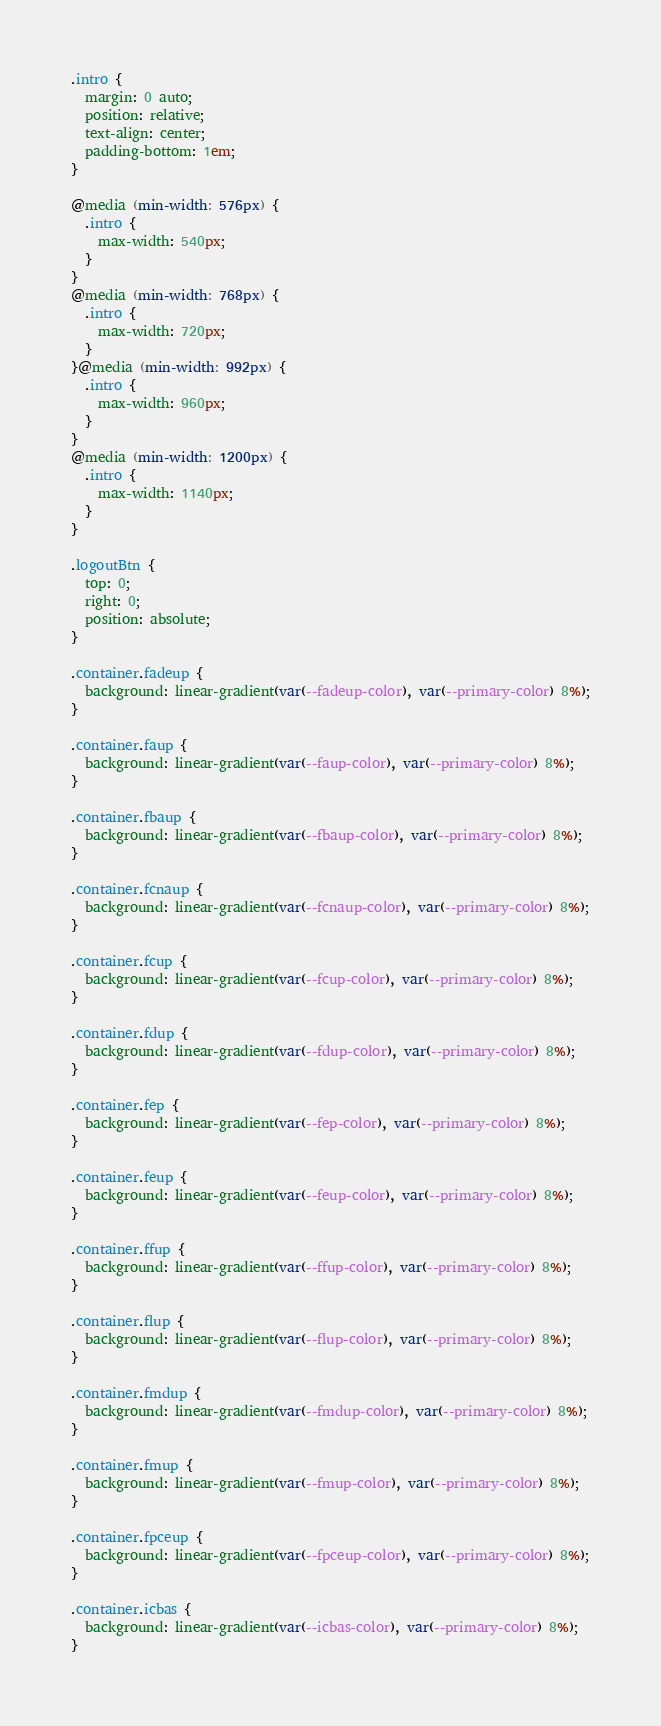<code> <loc_0><loc_0><loc_500><loc_500><_CSS_>.intro {
  margin: 0 auto;
  position: relative;
  text-align: center;
  padding-bottom: 1em;
}

@media (min-width: 576px) {
  .intro {
    max-width: 540px;
  }
}
@media (min-width: 768px) {
  .intro {
    max-width: 720px;
  }
}@media (min-width: 992px) {
  .intro {
    max-width: 960px;
  }
}
@media (min-width: 1200px) {
  .intro {
    max-width: 1140px;
  }
}

.logoutBtn {
  top: 0;
  right: 0;
  position: absolute;
}

.container.fadeup {
  background: linear-gradient(var(--fadeup-color), var(--primary-color) 8%);
}

.container.faup {
  background: linear-gradient(var(--faup-color), var(--primary-color) 8%);
}

.container.fbaup {
  background: linear-gradient(var(--fbaup-color), var(--primary-color) 8%);
}

.container.fcnaup {
  background: linear-gradient(var(--fcnaup-color), var(--primary-color) 8%);
}

.container.fcup {
  background: linear-gradient(var(--fcup-color), var(--primary-color) 8%);
}

.container.fdup {
  background: linear-gradient(var(--fdup-color), var(--primary-color) 8%);
}

.container.fep {
  background: linear-gradient(var(--fep-color), var(--primary-color) 8%);
}

.container.feup {
  background: linear-gradient(var(--feup-color), var(--primary-color) 8%);
}

.container.ffup {
  background: linear-gradient(var(--ffup-color), var(--primary-color) 8%);
}

.container.flup {
  background: linear-gradient(var(--flup-color), var(--primary-color) 8%);
}

.container.fmdup {
  background: linear-gradient(var(--fmdup-color), var(--primary-color) 8%);
}

.container.fmup {
  background: linear-gradient(var(--fmup-color), var(--primary-color) 8%);
}

.container.fpceup {
  background: linear-gradient(var(--fpceup-color), var(--primary-color) 8%);
}

.container.icbas {
  background: linear-gradient(var(--icbas-color), var(--primary-color) 8%);
}
</code> 